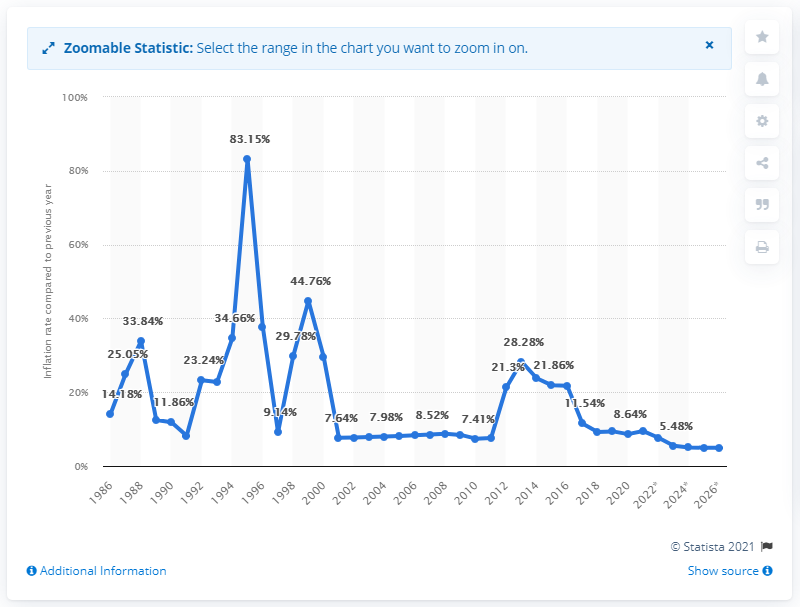Draw attention to some important aspects in this diagram. In 2020, the inflation rate in Malawi was 8.64%. 